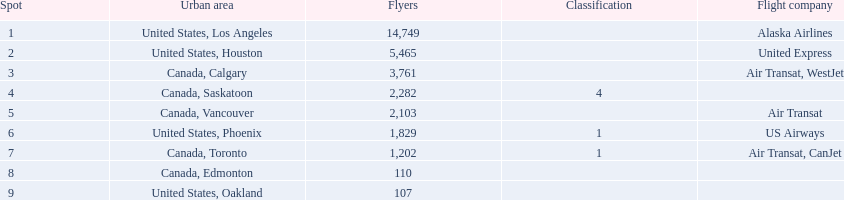What are all the cities? United States, Los Angeles, United States, Houston, Canada, Calgary, Canada, Saskatoon, Canada, Vancouver, United States, Phoenix, Canada, Toronto, Canada, Edmonton, United States, Oakland. How many passengers do they service? 14,749, 5,465, 3,761, 2,282, 2,103, 1,829, 1,202, 110, 107. Which city, when combined with los angeles, totals nearly 19,000? Canada, Calgary. 